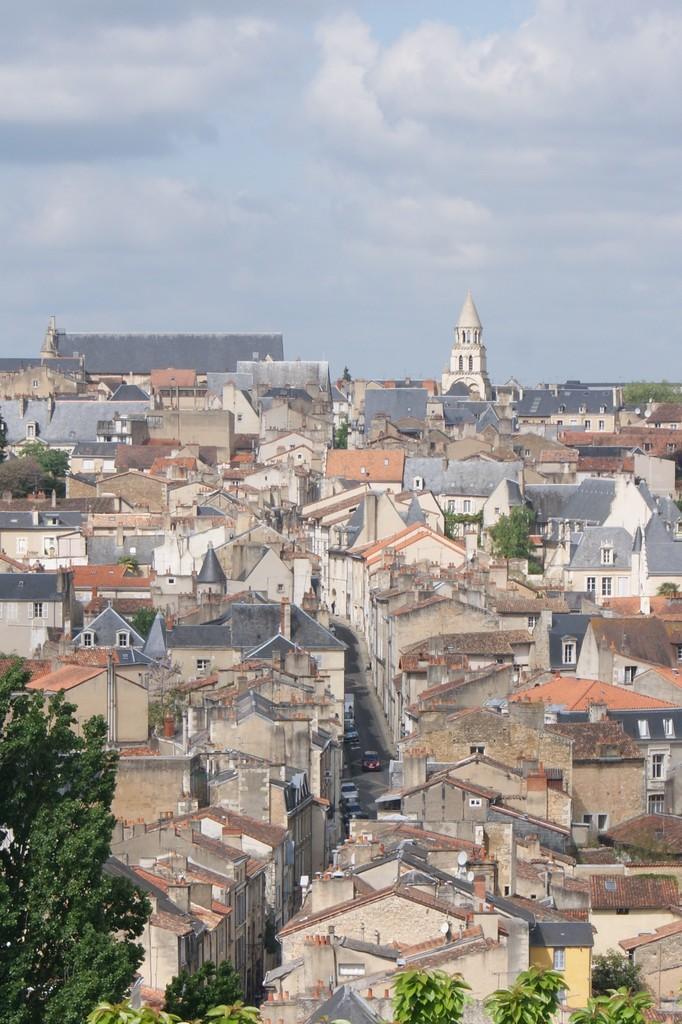Can you describe this image briefly? As we can see in the image there are buildings, windows, vehicles and trees. At the top there is sky and there are clouds. 